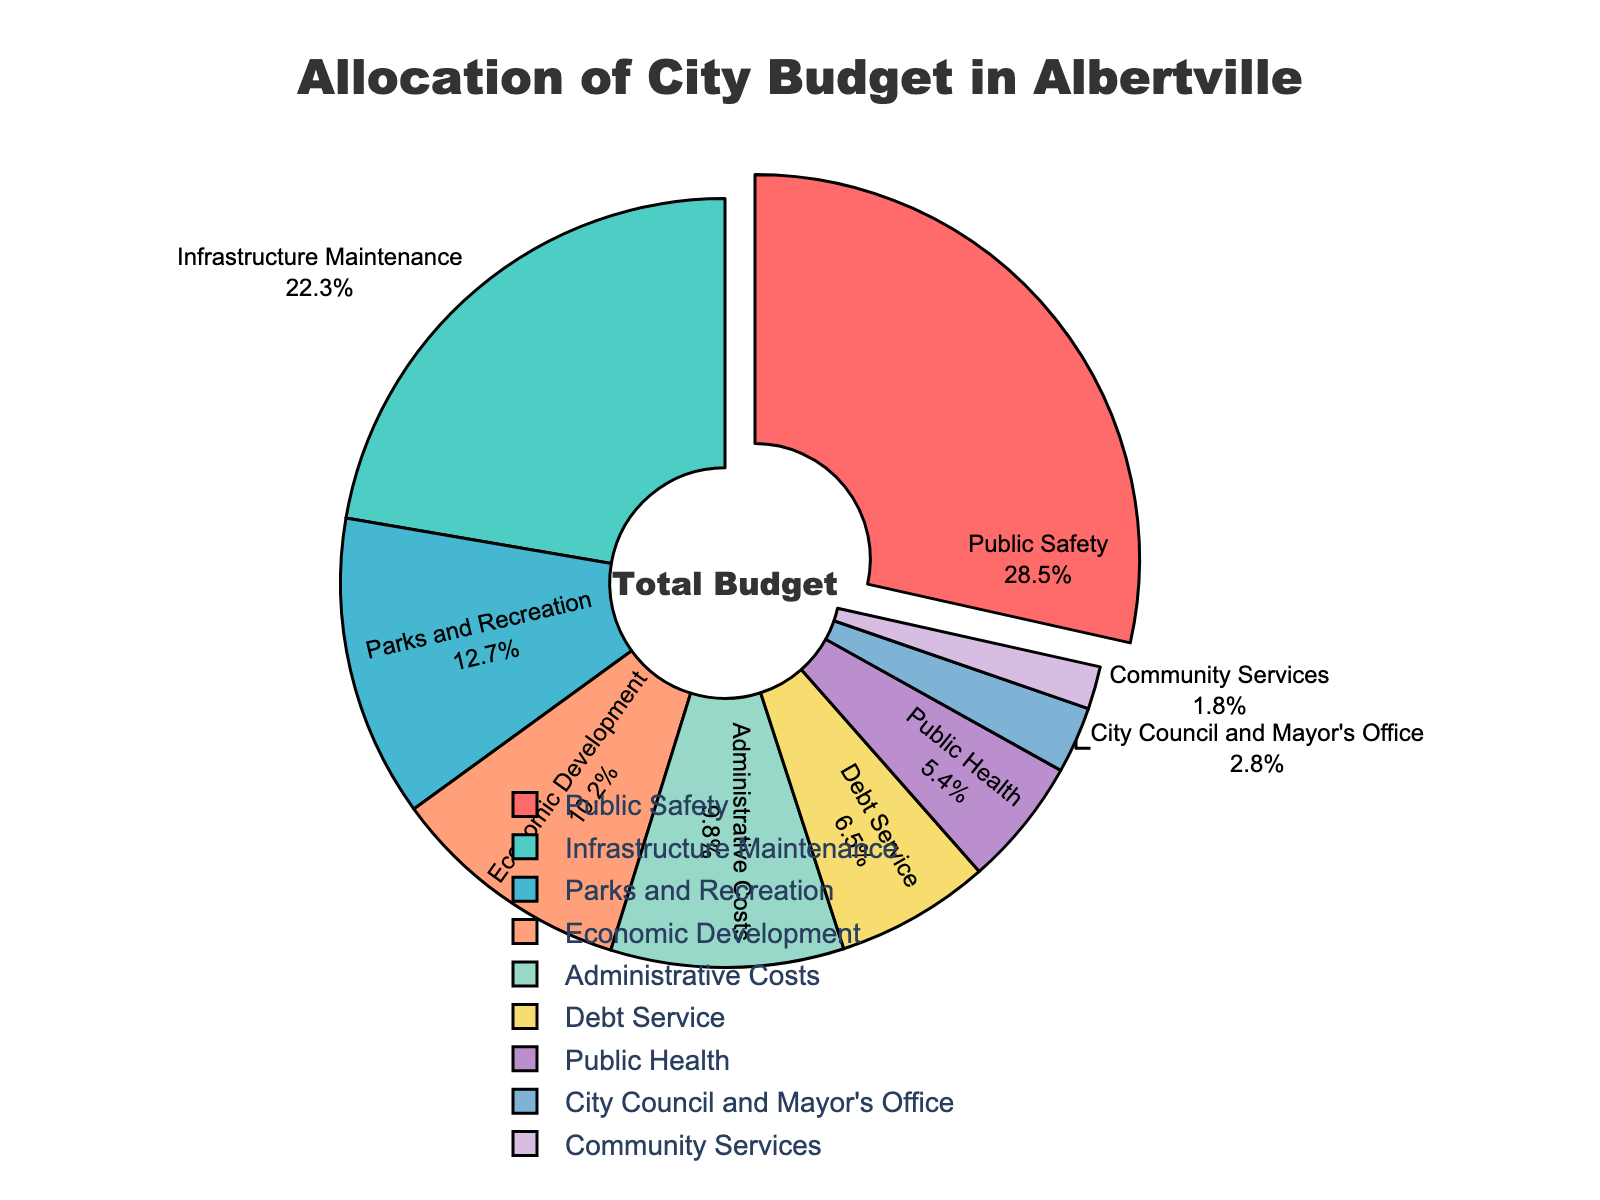What percentage of the city budget is allocated to Public Safety? The label on the pie chart for Public Safety shows 28.5%.
Answer: 28.5% Is the budget for Infrastructure Maintenance greater than the budget for Economic Development? The pie chart shows Infrastructure Maintenance at 22.3% and Economic Development at 10.2%; 22.3% is greater than 10.2%.
Answer: Yes Which category has the smallest allocation in the city budget? The label on the pie chart with the smallest percentage is Community Services at 1.8%.
Answer: Community Services What is the difference in percentage allocation between Public Safety and Parks and Recreation? The allocation for Public Safety is 28.5%, and for Parks and Recreation, it is 12.7%. The difference is 28.5% - 12.7%.
Answer: 15.8% What total percentage is allocated to Public Health and Debt Service combined? The percentages for Public Health and Debt Service are 5.4% and 6.5%, respectively. The total is 5.4% + 6.5%.
Answer: 11.9% How much more is allocated to Administrative Costs compared to Community Services? Administrative Costs are allocated 9.8%, and Community Services 1.8%. The difference is 9.8% - 1.8%.
Answer: 8% Which category is the second-largest in terms of budget allocation? The second-largest slice in the pie chart, after Public Safety (28.5%), is Infrastructure Maintenance, which is 22.3%.
Answer: Infrastructure Maintenance Is the percentage allocated to Public Health less than Debt Service? Public Health is allocated 5.4%, and Debt Service is 6.5%. 5.4% is less than 6.5%.
Answer: Yes What is the combined percentage of the City Council and Mayor's Office and Community Services? The percentages for the City Council and Mayor's Office and Community Services are 2.8% and 1.8%, respectively. The combined percentage is 2.8% + 1.8%.
Answer: 4.6% What color represents Public Safety on the pie chart? The slice for Public Safety is labeled as '#FF6B6B', which is a shade of red.
Answer: Red 